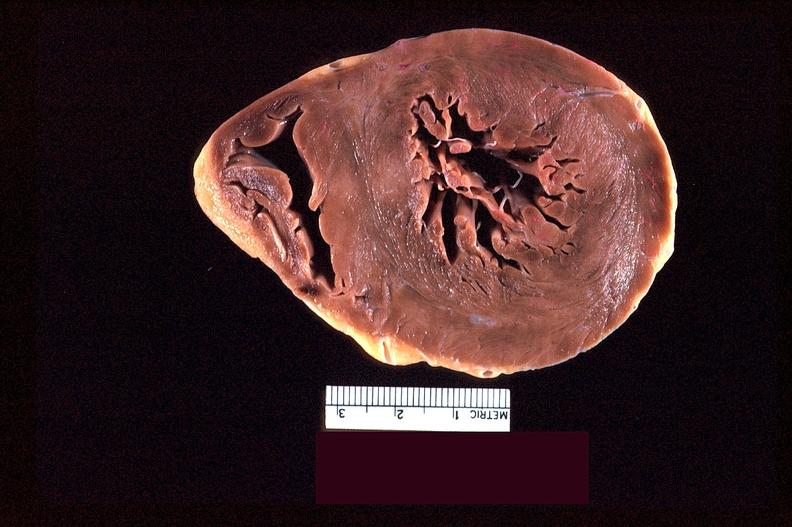does granulomata slide show heart slice, acute posterior myocardial infarction in patient with hypertension?
Answer the question using a single word or phrase. No 